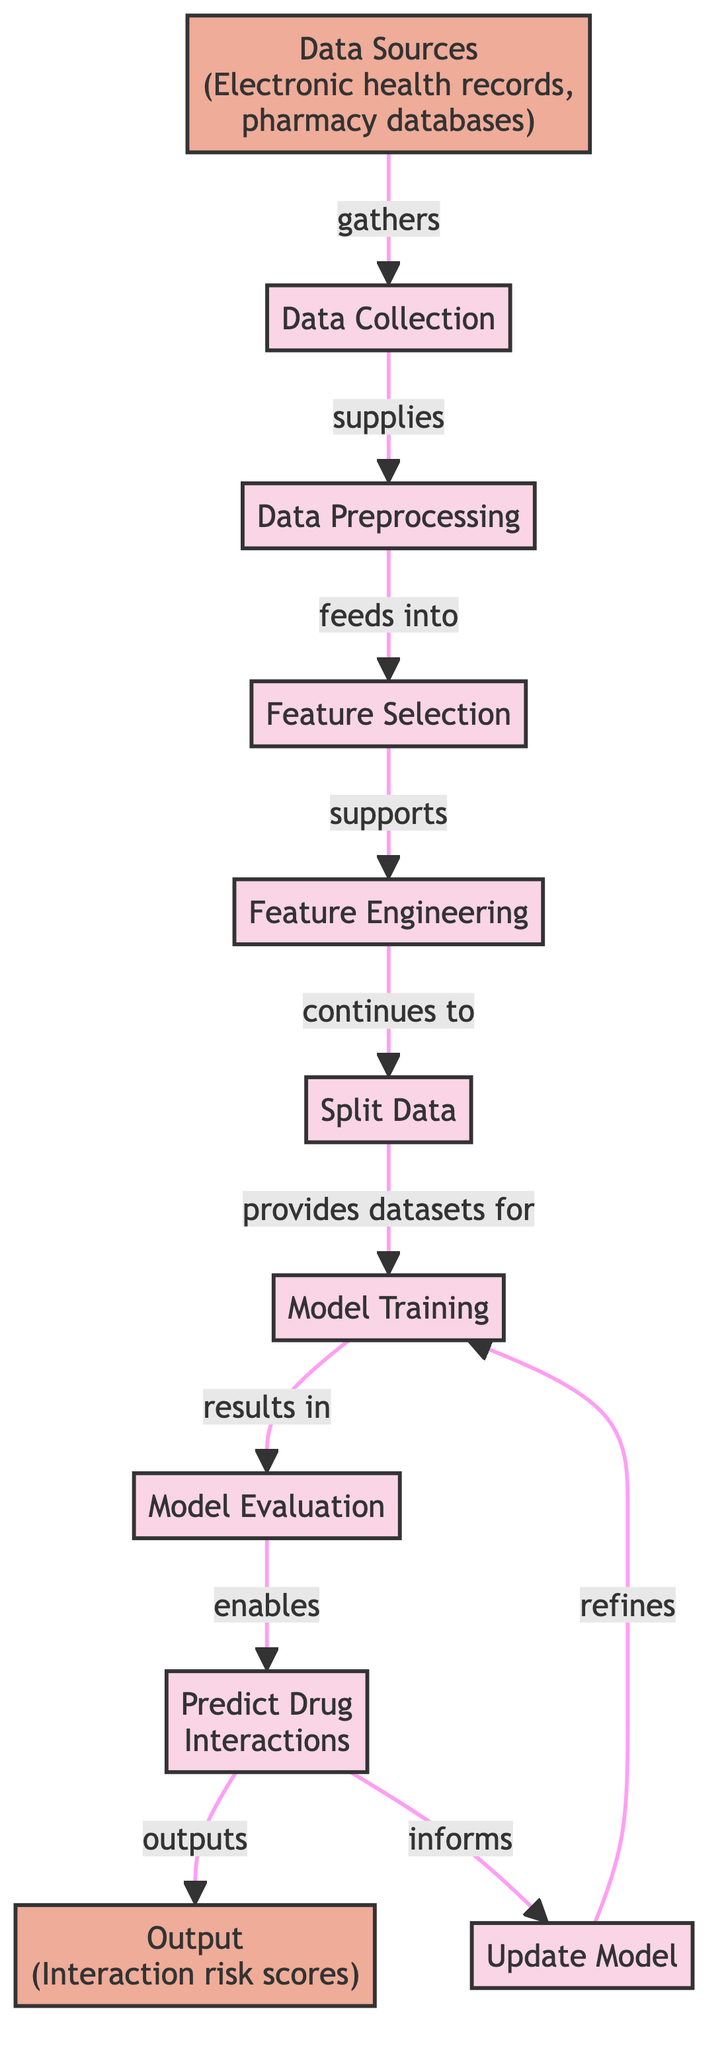What are the data sources used in the model? The diagram indicates that the data sources include electronic health records and pharmacy databases. These are the initial inputs that start the process.
Answer: Electronic health records, pharmacy databases What comes after data preprocessing in the flow? According to the diagram, after data preprocessing, the next step is feature selection. This follows a logical sequence where processed data is filtered for relevant qualities.
Answer: Feature selection How many main processes are shown in the diagram? The diagram lists nine main processes that include data collection, preprocessing, feature selection, engineering, data splitting, model training, evaluation, predicting interactions, and updating the model. Each represents a significant step in building the model.
Answer: Nine Which process results in model evaluation? The diagram shows that model training results in model evaluation. This indicates that model training is a key stage where the model learns from the data, leading to its evaluation.
Answer: Model training What does the output of the model represent? The output, as stated in the diagram, represents interaction risk scores, which are derived from the predictions made about drug interactions. This is crucial for understanding potential drug interactions for patient safety.
Answer: Interaction risk scores What informs the update of the model? The diagram indicates that the prediction of drug interactions informs the update model process. This suggests that as predictions are made, they provide insights that can refine the model for better accuracy in future predictions.
Answer: Predict drug interactions What is needed before model training can take place? According to the diagram, a split data step is necessary before the model training can occur. This implies that the data needs to be divided into training and testing sets for effective model learning.
Answer: Split data Which processes are part of feature engineering? The diagram does not specify individual sub-processes of feature engineering but indicates that it is supported by feature selection. These two steps work together to prepare the data for effective model training.
Answer: Feature selection, feature engineering How does the model training process relate to the model update process? The relationship shown in the diagram indicates that the model update process refines the model training. This demonstrates a feedback loop where learning from predictions can inform adjustments in training methods or data.
Answer: Refines model training 